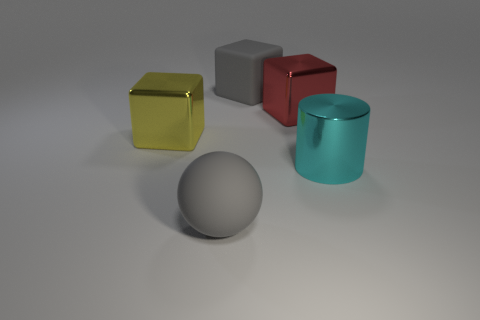How many other objects are the same shape as the cyan thing?
Provide a short and direct response. 0. What is the color of the matte sphere that is the same size as the metallic cylinder?
Your answer should be compact. Gray. How many cylinders are either large yellow things or gray matte objects?
Your response must be concise. 0. How many big gray cubes are there?
Your answer should be compact. 1. There is a red metal object; is its shape the same as the large gray rubber object to the right of the gray ball?
Your answer should be very brief. Yes. What is the size of the thing that is the same color as the big rubber sphere?
Make the answer very short. Large. How many things are either gray blocks or cubes?
Ensure brevity in your answer.  3. There is a big rubber object behind the matte thing that is in front of the large yellow object; what shape is it?
Give a very brief answer. Cube. There is a large gray object that is to the left of the large gray rubber block; is it the same shape as the red object?
Offer a very short reply. No. There is a yellow thing that is made of the same material as the big cylinder; what size is it?
Keep it short and to the point. Large. 